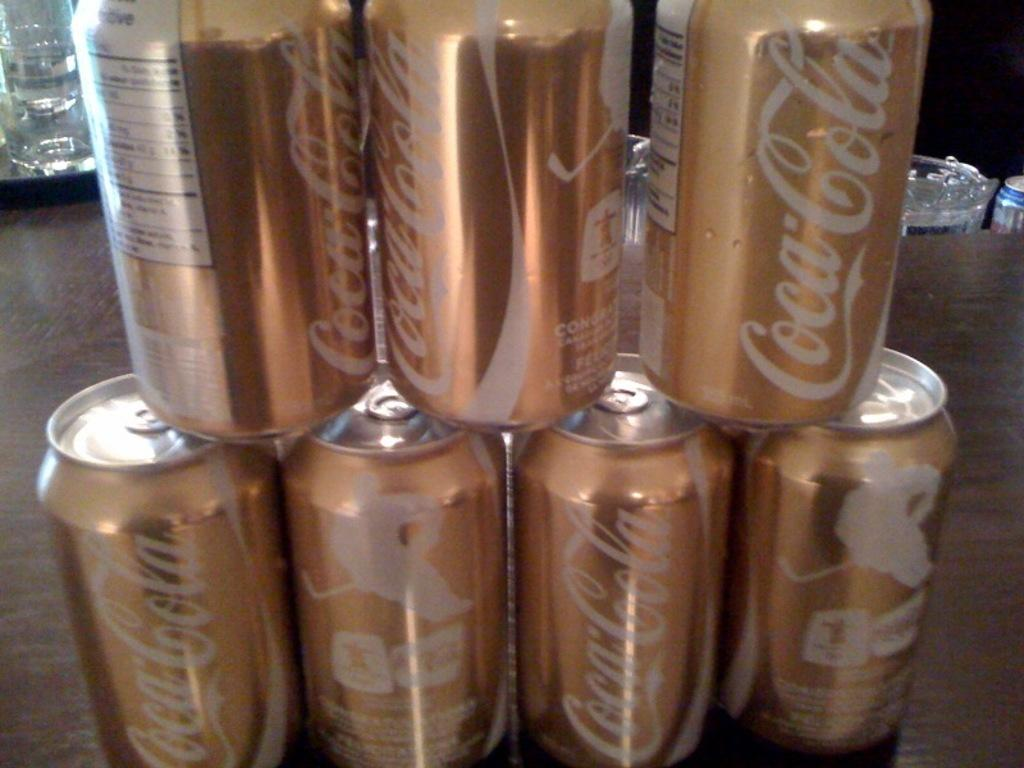<image>
Give a short and clear explanation of the subsequent image. White and gold tin coca cola branded cans of soda. 